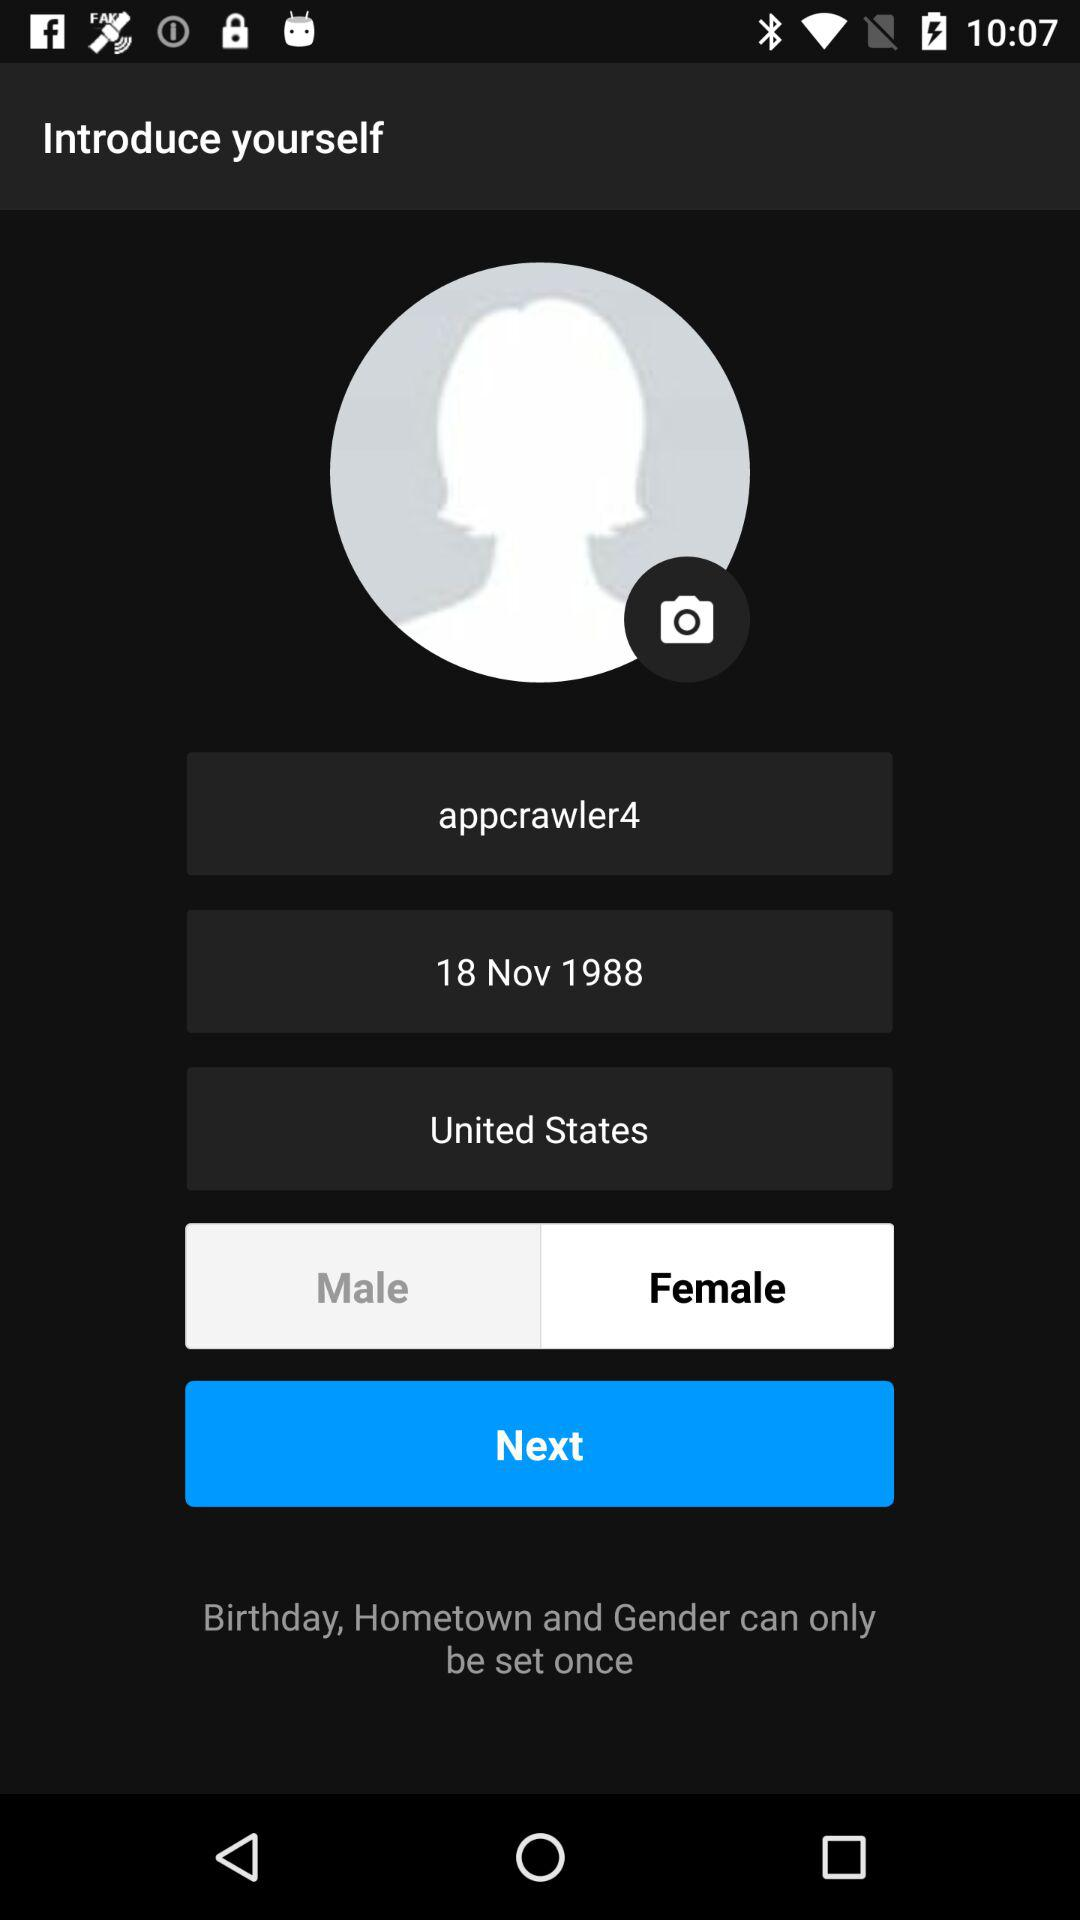Which gender is selected? The selected gender is female. 